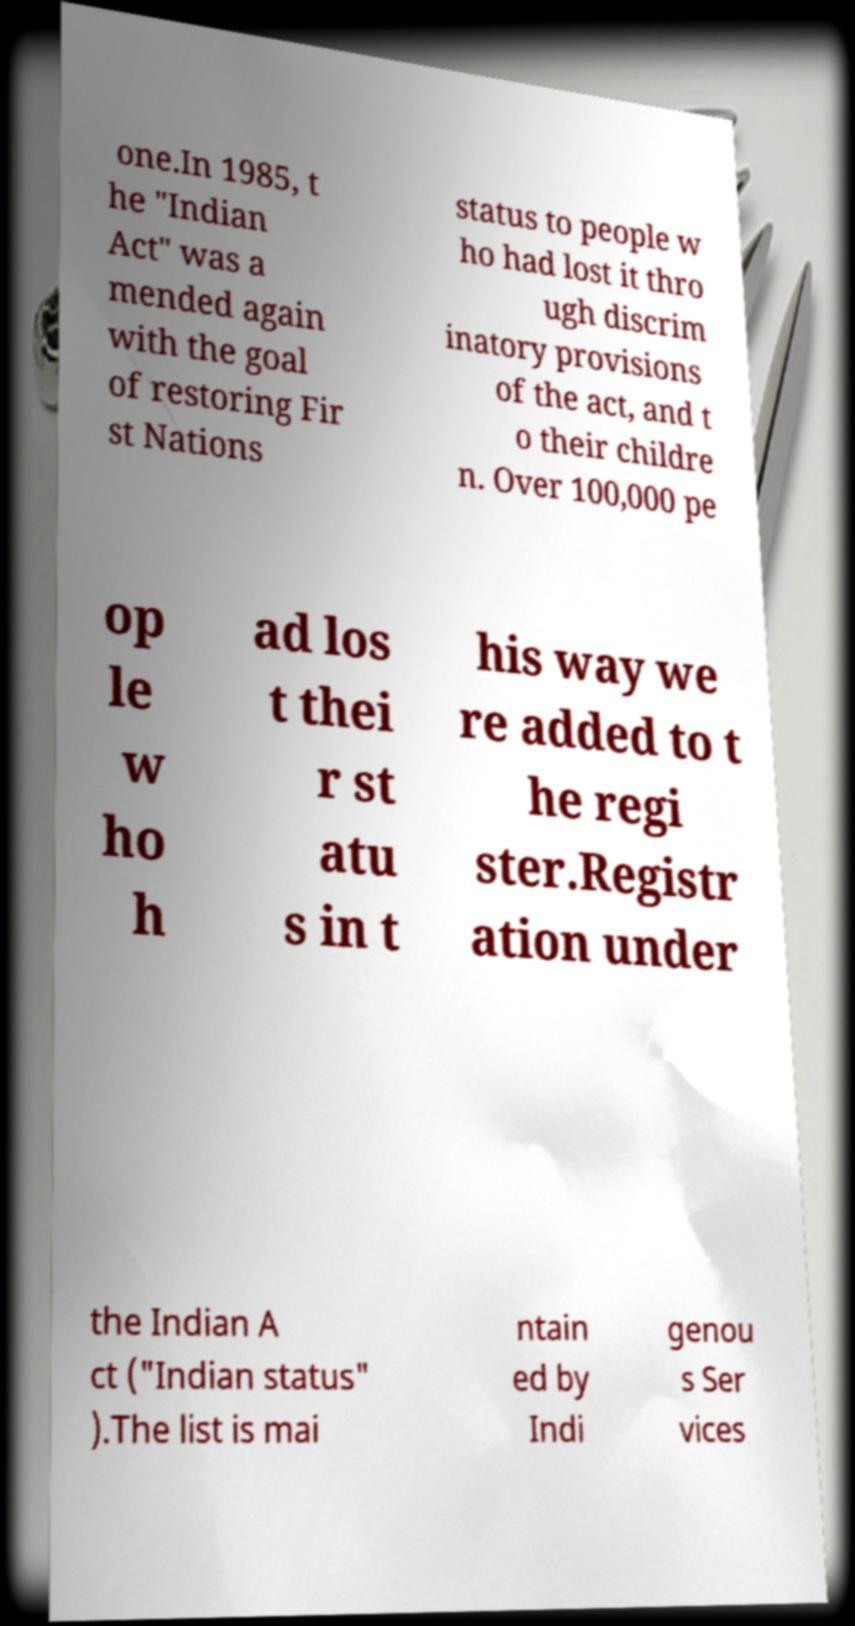Please identify and transcribe the text found in this image. one.In 1985, t he "Indian Act" was a mended again with the goal of restoring Fir st Nations status to people w ho had lost it thro ugh discrim inatory provisions of the act, and t o their childre n. Over 100,000 pe op le w ho h ad los t thei r st atu s in t his way we re added to t he regi ster.Registr ation under the Indian A ct ("Indian status" ).The list is mai ntain ed by Indi genou s Ser vices 